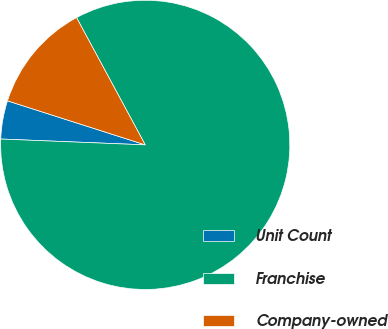Convert chart. <chart><loc_0><loc_0><loc_500><loc_500><pie_chart><fcel>Unit Count<fcel>Franchise<fcel>Company-owned<nl><fcel>4.28%<fcel>83.52%<fcel>12.2%<nl></chart> 